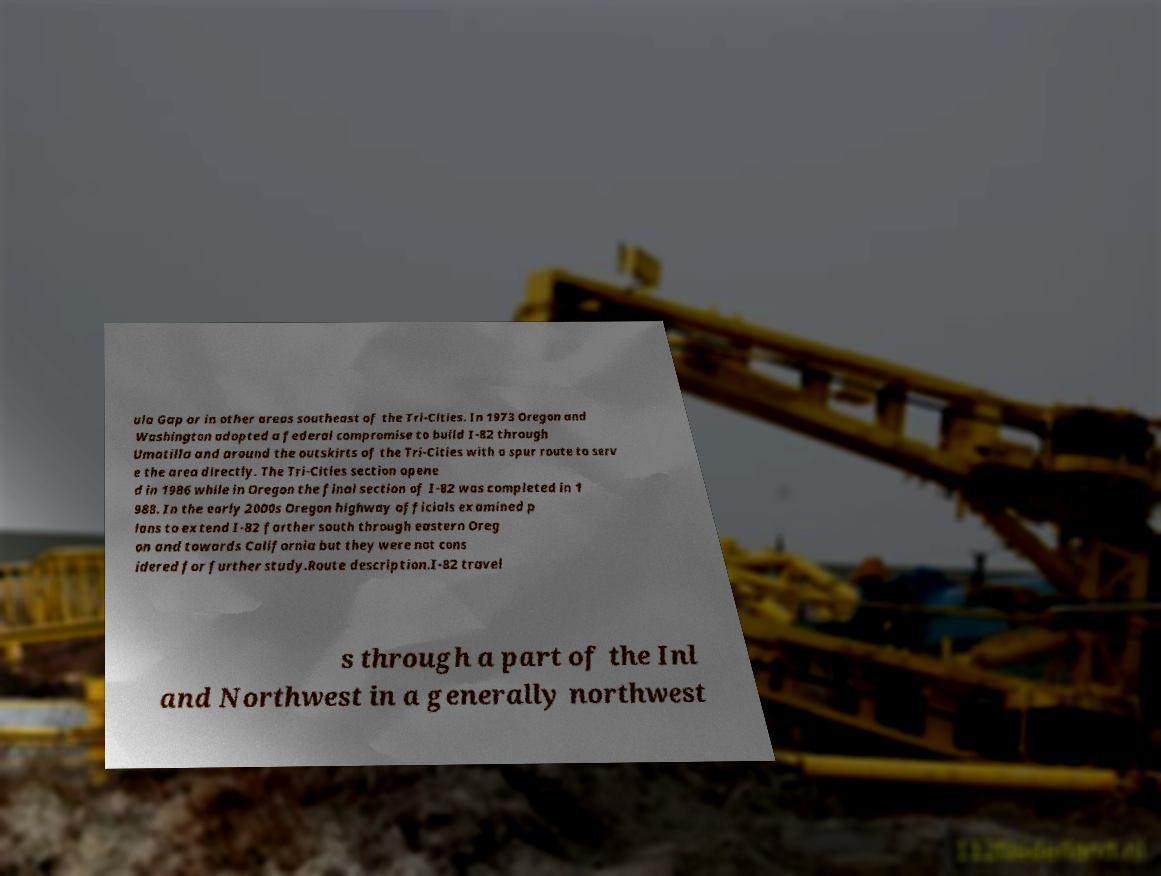Can you accurately transcribe the text from the provided image for me? ula Gap or in other areas southeast of the Tri-Cities. In 1973 Oregon and Washington adopted a federal compromise to build I-82 through Umatilla and around the outskirts of the Tri-Cities with a spur route to serv e the area directly. The Tri-Cities section opene d in 1986 while in Oregon the final section of I-82 was completed in 1 988. In the early 2000s Oregon highway officials examined p lans to extend I-82 farther south through eastern Oreg on and towards California but they were not cons idered for further study.Route description.I-82 travel s through a part of the Inl and Northwest in a generally northwest 